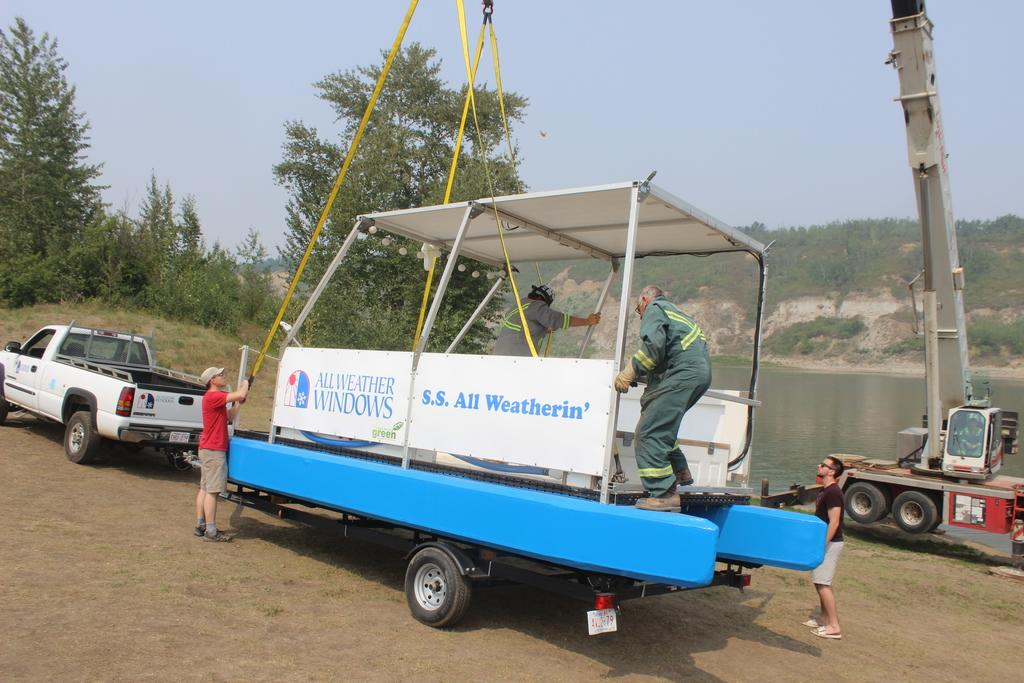What is the main subject in the picture? There is a crane in the picture. What else can be seen in the picture besides the crane? There is a vehicle with a trolley in the picture, and there are people standing near the crane and the vehicle. What are some people doing in the picture? Some people are standing on the trolley. What type of natural environment is visible in the picture? There are trees and water visible in the picture. What is the color of the sky in the picture? The sky is blue in the picture. What type of interest can be seen on the faces of the people in the picture? There is no indication of the people's emotions or interests in the picture, so it cannot be determined from the image. 